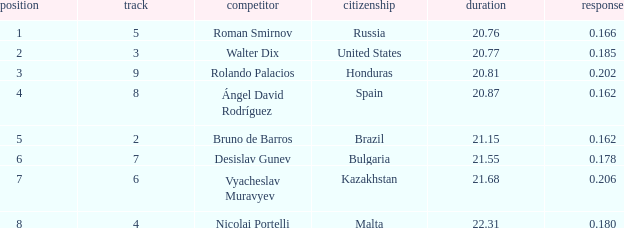What's Bulgaria's lane with a time more than 21.55? None. 